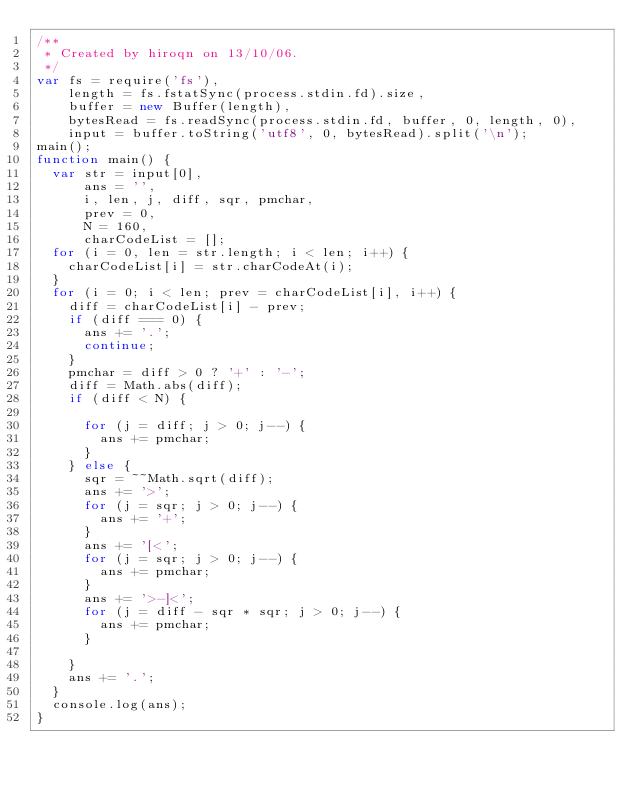Convert code to text. <code><loc_0><loc_0><loc_500><loc_500><_JavaScript_>/**
 * Created by hiroqn on 13/10/06.
 */
var fs = require('fs'),
    length = fs.fstatSync(process.stdin.fd).size,
    buffer = new Buffer(length),
    bytesRead = fs.readSync(process.stdin.fd, buffer, 0, length, 0),
    input = buffer.toString('utf8', 0, bytesRead).split('\n');
main();
function main() {
  var str = input[0],
      ans = '',
      i, len, j, diff, sqr, pmchar,
      prev = 0,
      N = 160,
      charCodeList = [];
  for (i = 0, len = str.length; i < len; i++) {
    charCodeList[i] = str.charCodeAt(i);
  }
  for (i = 0; i < len; prev = charCodeList[i], i++) {
    diff = charCodeList[i] - prev;
    if (diff === 0) {
      ans += '.';
      continue;
    }
    pmchar = diff > 0 ? '+' : '-';
    diff = Math.abs(diff);
    if (diff < N) {

      for (j = diff; j > 0; j--) {
        ans += pmchar;
      }
    } else {
      sqr = ~~Math.sqrt(diff);
      ans += '>';
      for (j = sqr; j > 0; j--) {
        ans += '+';
      }
      ans += '[<';
      for (j = sqr; j > 0; j--) {
        ans += pmchar;
      }
      ans += '>-]<';
      for (j = diff - sqr * sqr; j > 0; j--) {
        ans += pmchar;
      }

    }
    ans += '.';
  }
  console.log(ans);
}</code> 